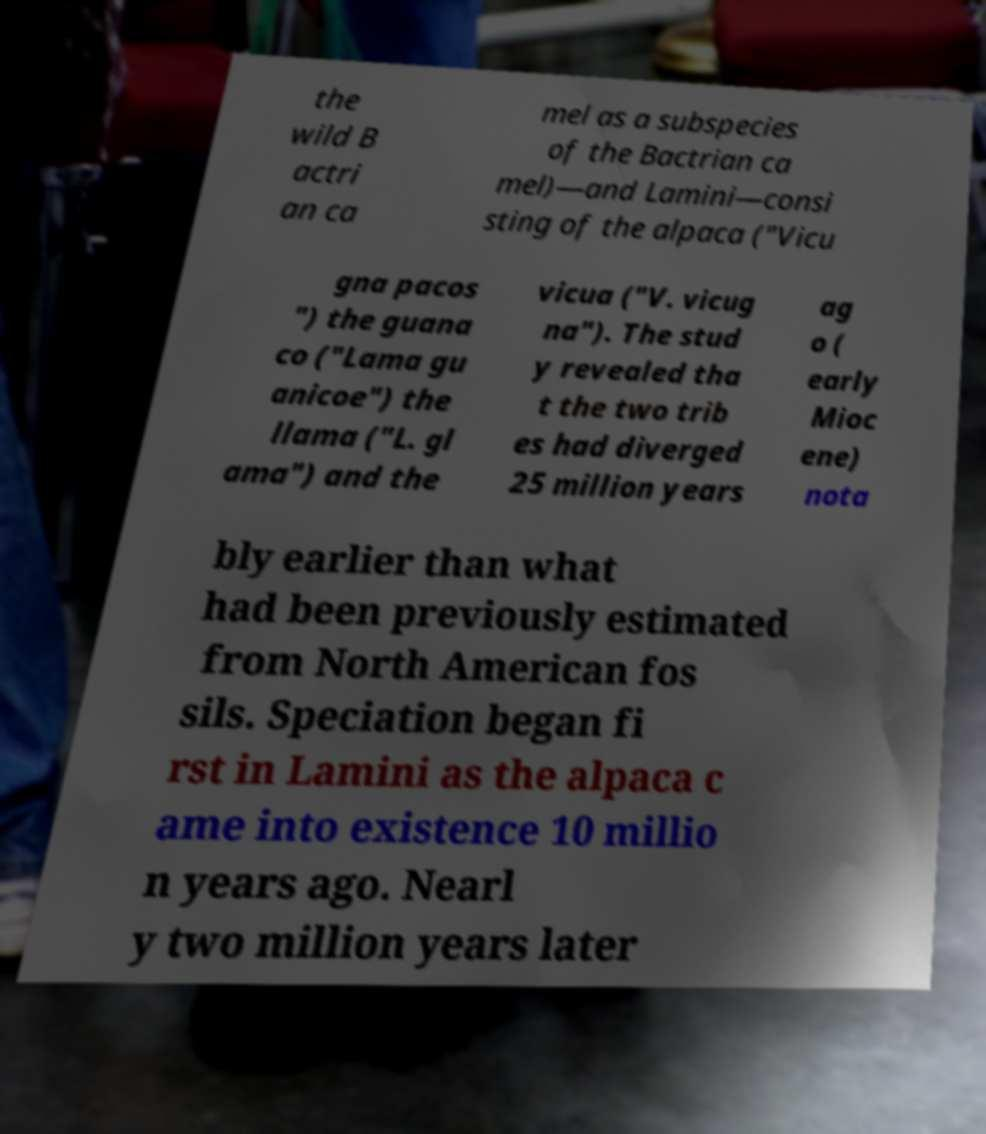What messages or text are displayed in this image? I need them in a readable, typed format. the wild B actri an ca mel as a subspecies of the Bactrian ca mel)—and Lamini—consi sting of the alpaca ("Vicu gna pacos ") the guana co ("Lama gu anicoe") the llama ("L. gl ama") and the vicua ("V. vicug na"). The stud y revealed tha t the two trib es had diverged 25 million years ag o ( early Mioc ene) nota bly earlier than what had been previously estimated from North American fos sils. Speciation began fi rst in Lamini as the alpaca c ame into existence 10 millio n years ago. Nearl y two million years later 